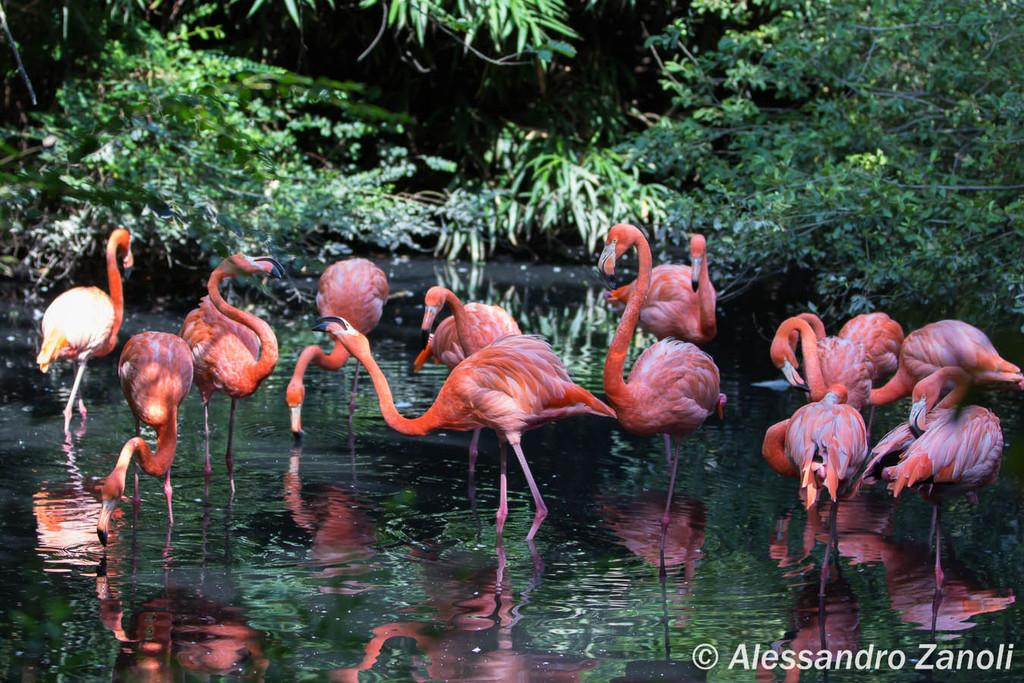What is the primary element in the image? There is water in the image. What animals can be seen in the water? There are flamingos in the water. What can be seen in the background of the image? There are trees visible in the background of the image. Is there any text present in the image? Yes, there is text written on the image. How many cobwebs can be seen in the image? There are no cobwebs present in the image. What role does the actor play in the image? There is no actor present in the image. 